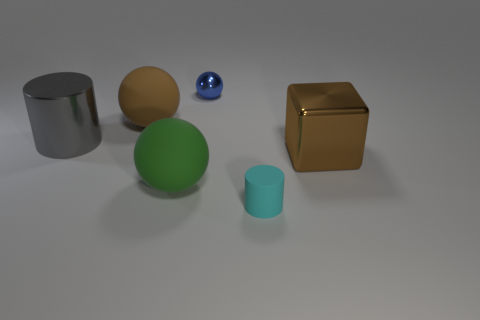What material is the tiny blue thing?
Offer a terse response. Metal. There is a blue metal object that is the same shape as the large green thing; what size is it?
Give a very brief answer. Small. What number of other things are there of the same material as the blue sphere
Keep it short and to the point. 2. Are there the same number of tiny blue metallic spheres that are on the right side of the blue metallic thing and small brown blocks?
Your answer should be very brief. Yes. Is the size of the metallic thing right of the cyan object the same as the blue object?
Keep it short and to the point. No. There is a tiny blue metal ball; what number of large metal things are in front of it?
Your response must be concise. 2. There is a object that is both behind the big green matte thing and in front of the big metal cylinder; what is it made of?
Your answer should be very brief. Metal. What number of small things are either purple metal cylinders or gray cylinders?
Provide a succinct answer. 0. What size is the blue object?
Provide a short and direct response. Small. There is a gray thing; what shape is it?
Your answer should be very brief. Cylinder. 